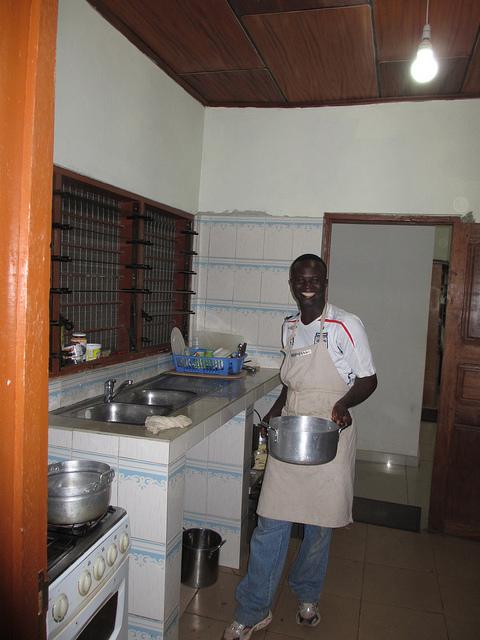How many bottles of wine?
Write a very short answer. 0. What is the man doing?
Quick response, please. Cooking. Does this person look happy?
Concise answer only. Yes. Is this a bathroom?
Keep it brief. No. What room is shown here?
Write a very short answer. Kitchen. Is there a stack of plates?
Be succinct. No. What is the person holding?
Answer briefly. Pot. How many workers are there?
Keep it brief. 1. What color is the wood?
Answer briefly. Brown. 